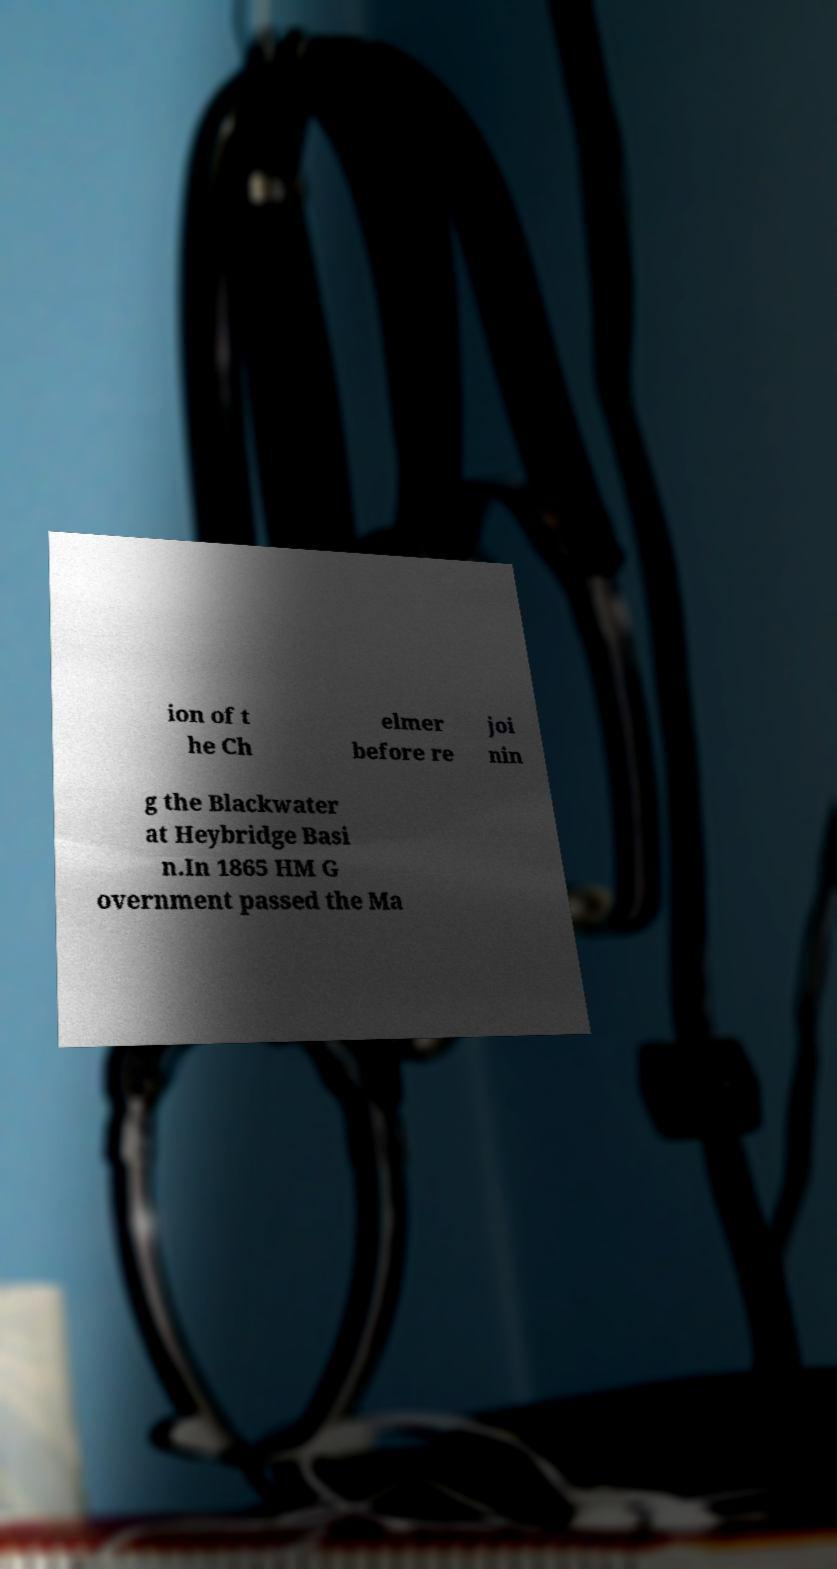Please read and relay the text visible in this image. What does it say? ion of t he Ch elmer before re joi nin g the Blackwater at Heybridge Basi n.In 1865 HM G overnment passed the Ma 